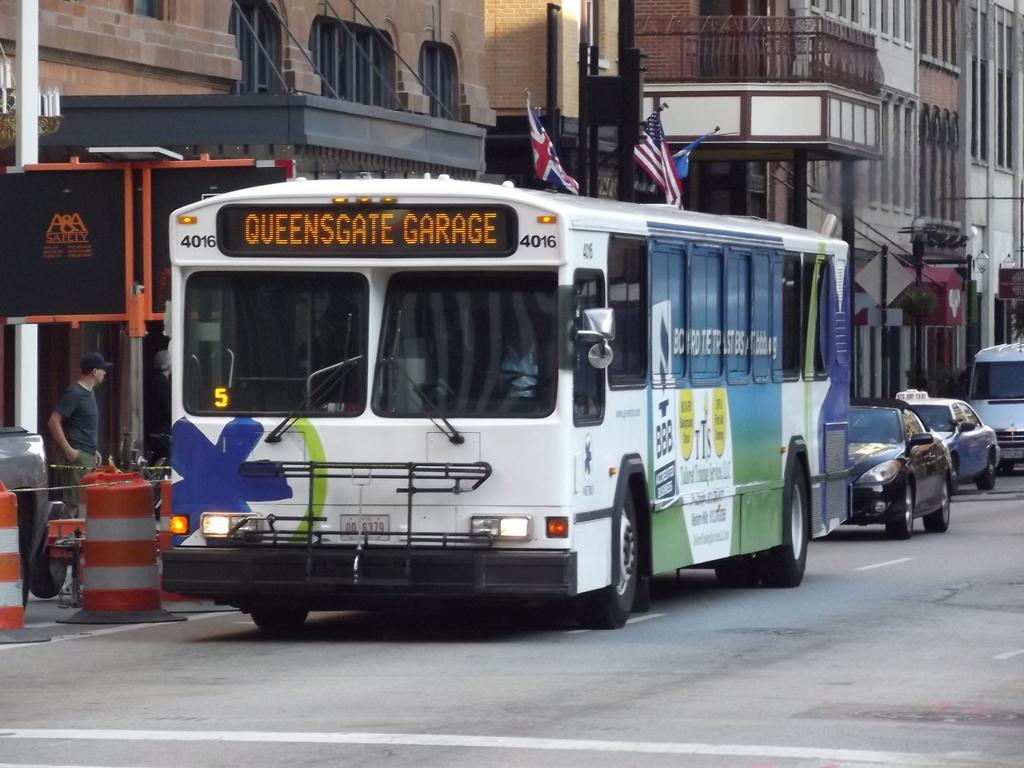What can be seen on the road in the image? There are vehicles on the road in the image. What type of structures can be seen in the image? There are buildings visible in the image. What are the vertical structures in the image? There are poles in the image. What is attached to the poles in the image? There are flags in the image. What are the circular objects in the image? There are circular objects in the image. What is the signage in the image? There is a sign board in the image. What are the thin, stretched objects in the image? There are cables in the image. What type of silver material can be seen in the bedroom in the image? There is no bedroom or silver material present in the image. What type of school can be seen in the image? There is no school present in the image. 